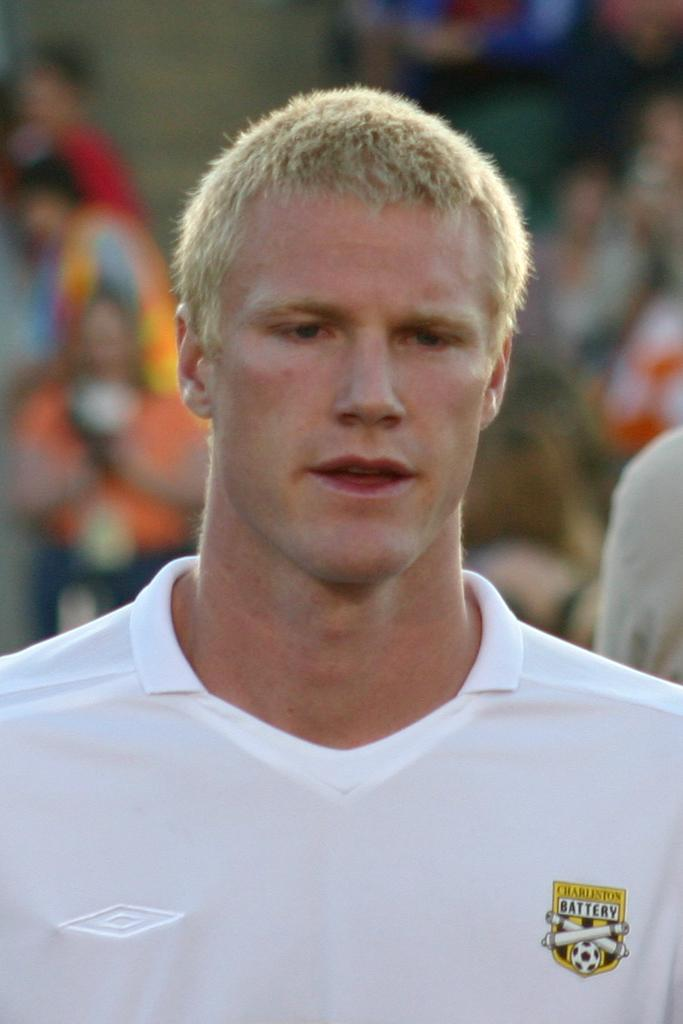<image>
Describe the image concisely. Man wearing a white shirt that says Charleston Battery. 